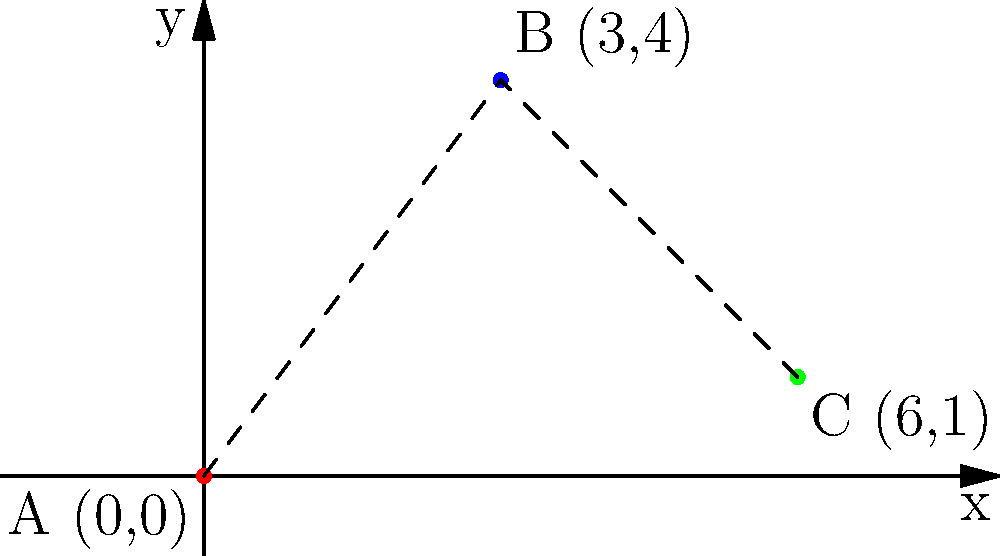As part of our environmental compliance efforts, we need to strategically place air quality sensors. Given three potential locations for sensor placement: A(0,0), B(3,4), and C(6,1), what is the position vector from A to the midpoint of line segment BC? Express your answer in vector notation. To find the position vector from A to the midpoint of BC, we'll follow these steps:

1. Find the midpoint of BC:
   - B = (3,4) and C = (6,1)
   - Midpoint formula: $M = (\frac{x_1 + x_2}{2}, \frac{y_1 + y_2}{2})$
   - $M_x = \frac{3 + 6}{2} = \frac{9}{2} = 4.5$
   - $M_y = \frac{4 + 1}{2} = \frac{5}{2} = 2.5$
   - Midpoint M = (4.5, 2.5)

2. Calculate the vector from A to M:
   - A = (0,0)
   - Vector AM = M - A = (4.5 - 0, 2.5 - 0) = (4.5, 2.5)

3. Express the result in vector notation:
   $\vec{AM} = \langle 4.5, 2.5 \rangle$

This vector represents the optimal placement for the air quality sensor, considering the midpoint between locations B and C, relative to the origin point A.
Answer: $\langle 4.5, 2.5 \rangle$ 